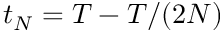Convert formula to latex. <formula><loc_0><loc_0><loc_500><loc_500>{ t _ { N } = T - T / ( 2 N ) }</formula> 